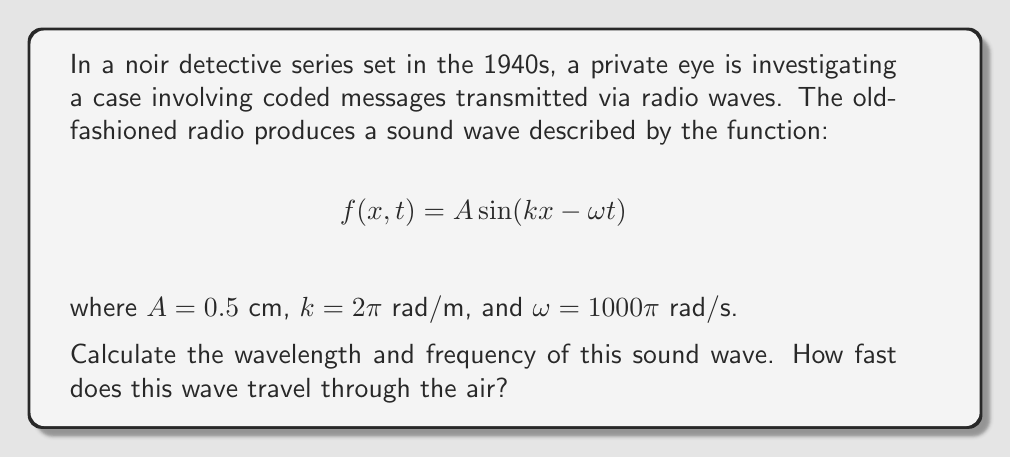Help me with this question. Let's approach this step-by-step:

1) For a wave equation of the form $f(x,t) = A \sin(kx - \omega t)$:
   - $A$ is the amplitude
   - $k$ is the wave number
   - $\omega$ is the angular frequency

2) To find the wavelength $\lambda$:
   The wave number $k$ is related to the wavelength by: $k = \frac{2\pi}{\lambda}$
   Given $k = 2\pi$ rad/m, we can solve for $\lambda$:
   $$\lambda = \frac{2\pi}{k} = \frac{2\pi}{2\pi} = 1 \text{ m}$$

3) To find the frequency $f$:
   The angular frequency $\omega$ is related to the frequency by: $\omega = 2\pi f$
   Given $\omega = 1000\pi$ rad/s, we can solve for $f$:
   $$f = \frac{\omega}{2\pi} = \frac{1000\pi}{2\pi} = 500 \text{ Hz}$$

4) To find the wave speed $v$:
   We can use the wave equation: $v = \lambda f$
   $$v = 1 \text{ m} \times 500 \text{ Hz} = 500 \text{ m/s}$$

   Alternatively, we could use: $v = \frac{\omega}{k} = \frac{1000\pi}{2\pi} = 500 \text{ m/s}$
Answer: Wavelength: 1 m, Frequency: 500 Hz, Wave speed: 500 m/s 